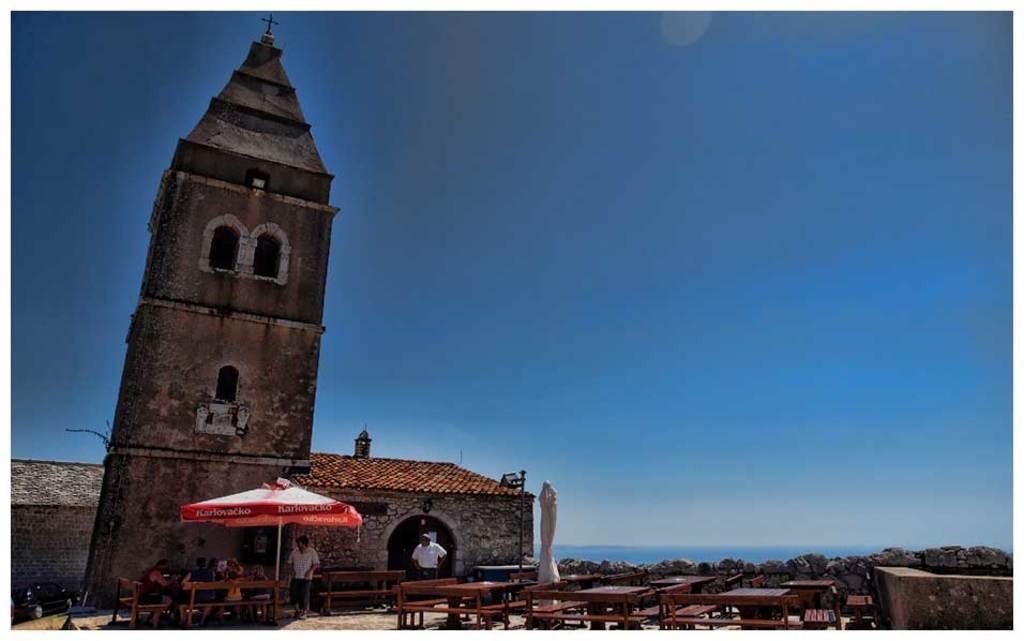Please provide a concise description of this image. In this image there is a tower and we can see sheds. At the bottom there are benches and we can see people. There is a tent. On the right there is a wall. In the background there is water. At the top there is sky. 